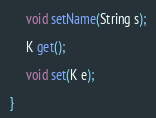Convert code to text. <code><loc_0><loc_0><loc_500><loc_500><_Java_>
	 void setName(String s);

	 K get();

	 void set(K e);

}
</code> 